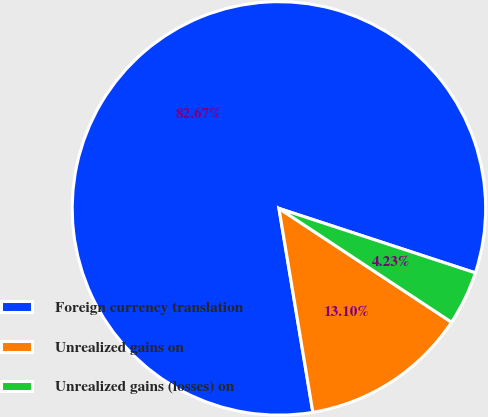<chart> <loc_0><loc_0><loc_500><loc_500><pie_chart><fcel>Foreign currency translation<fcel>Unrealized gains on<fcel>Unrealized gains (losses) on<nl><fcel>82.67%<fcel>13.1%<fcel>4.23%<nl></chart> 